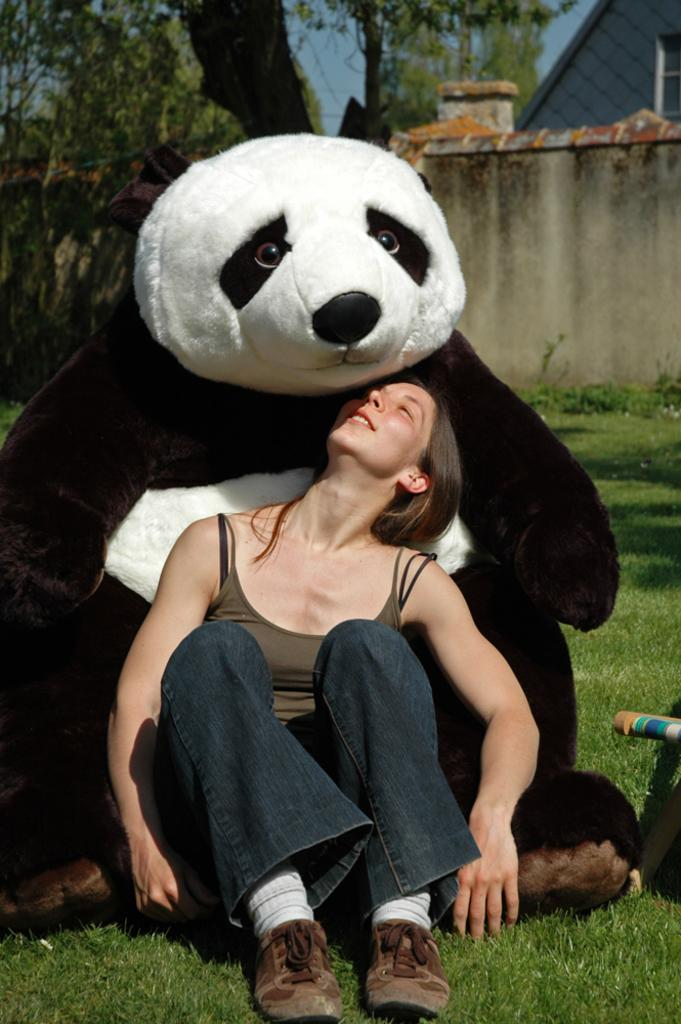What is the woman in the image doing? The woman is sitting on the ground in the image. What is the woman's facial expression? The woman is smiling in the image. What object is present in the image with the woman? There is a teddy bear in the image. What type of natural environment can be seen in the image? There are trees in the image. What type of structure is visible in the image? There is a wall in the image. What is visible in the background of the image? The sky is visible in the background of the image. What color is the crayon that the stranger is holding in the image? There is no stranger or crayon present in the image. 